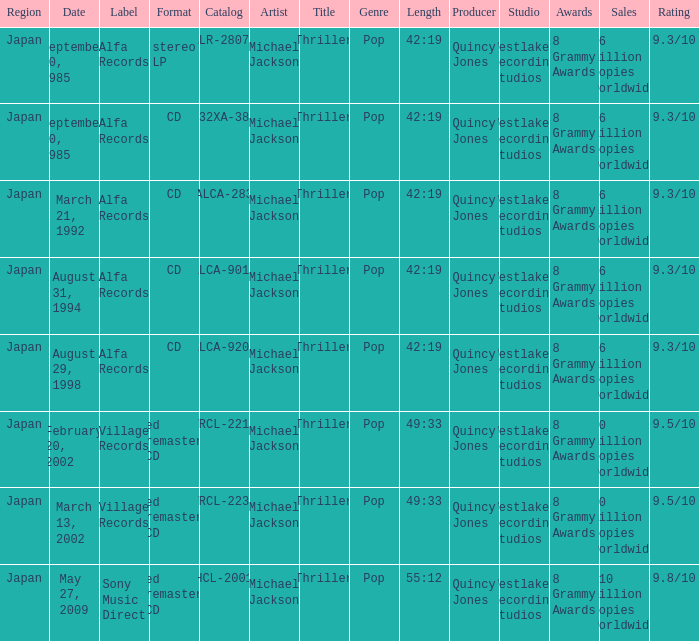Which Catalog was formated as a CD under the label Alfa Records? 32XA-38, ALCA-283, ALCA-9013, ALCA-9208. 